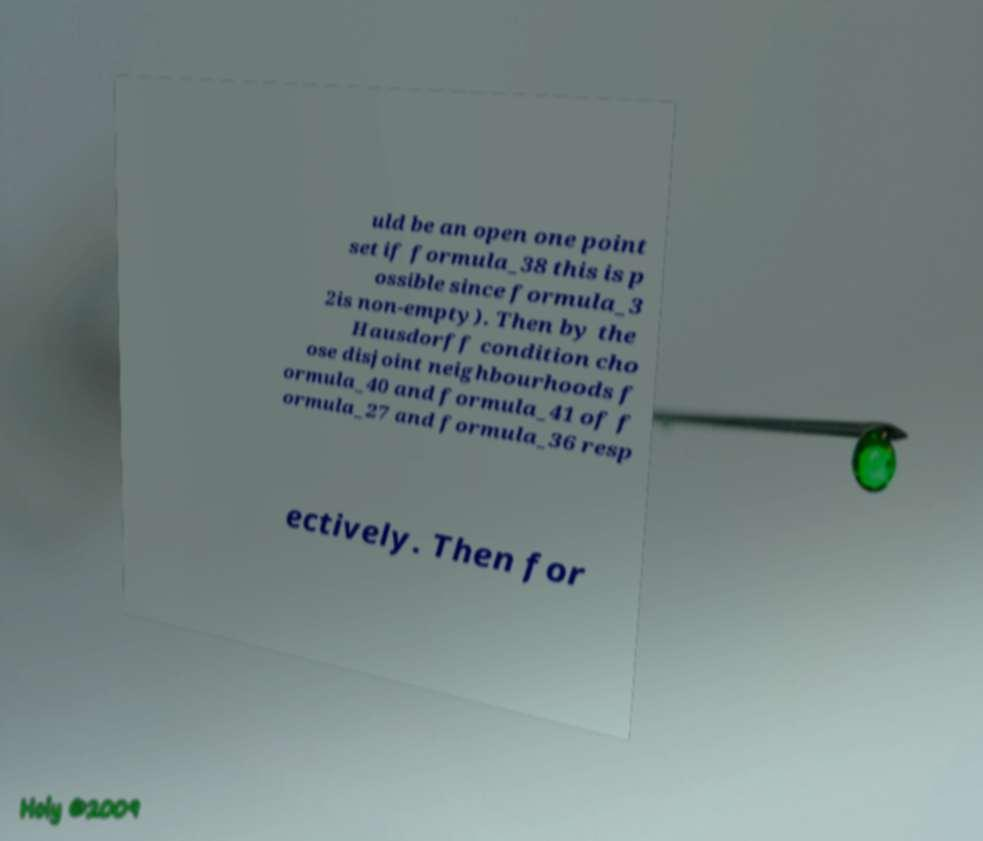Could you assist in decoding the text presented in this image and type it out clearly? uld be an open one point set if formula_38 this is p ossible since formula_3 2is non-empty). Then by the Hausdorff condition cho ose disjoint neighbourhoods f ormula_40 and formula_41 of f ormula_27 and formula_36 resp ectively. Then for 